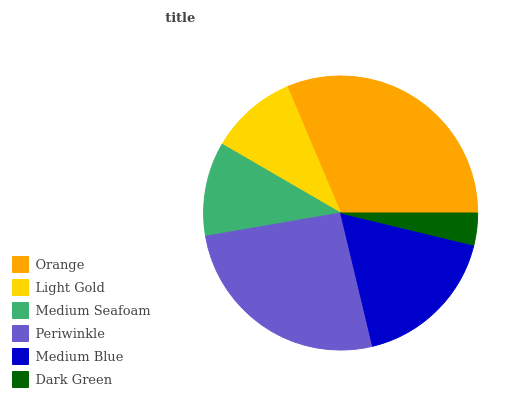Is Dark Green the minimum?
Answer yes or no. Yes. Is Orange the maximum?
Answer yes or no. Yes. Is Light Gold the minimum?
Answer yes or no. No. Is Light Gold the maximum?
Answer yes or no. No. Is Orange greater than Light Gold?
Answer yes or no. Yes. Is Light Gold less than Orange?
Answer yes or no. Yes. Is Light Gold greater than Orange?
Answer yes or no. No. Is Orange less than Light Gold?
Answer yes or no. No. Is Medium Blue the high median?
Answer yes or no. Yes. Is Medium Seafoam the low median?
Answer yes or no. Yes. Is Orange the high median?
Answer yes or no. No. Is Light Gold the low median?
Answer yes or no. No. 